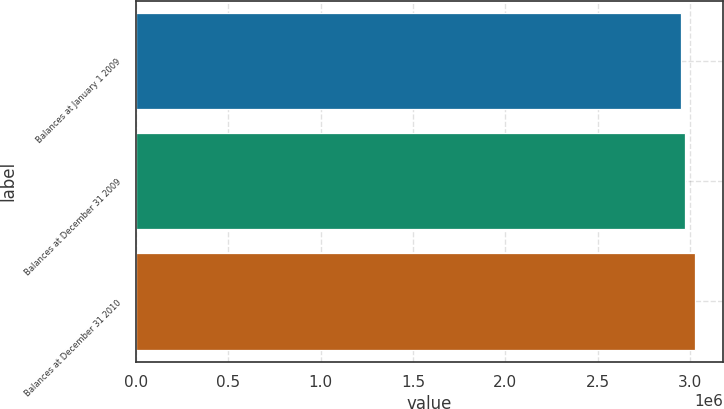Convert chart to OTSL. <chart><loc_0><loc_0><loc_500><loc_500><bar_chart><fcel>Balances at January 1 2009<fcel>Balances at December 31 2009<fcel>Balances at December 31 2010<nl><fcel>2.95254e+06<fcel>2.9735e+06<fcel>3.02713e+06<nl></chart> 